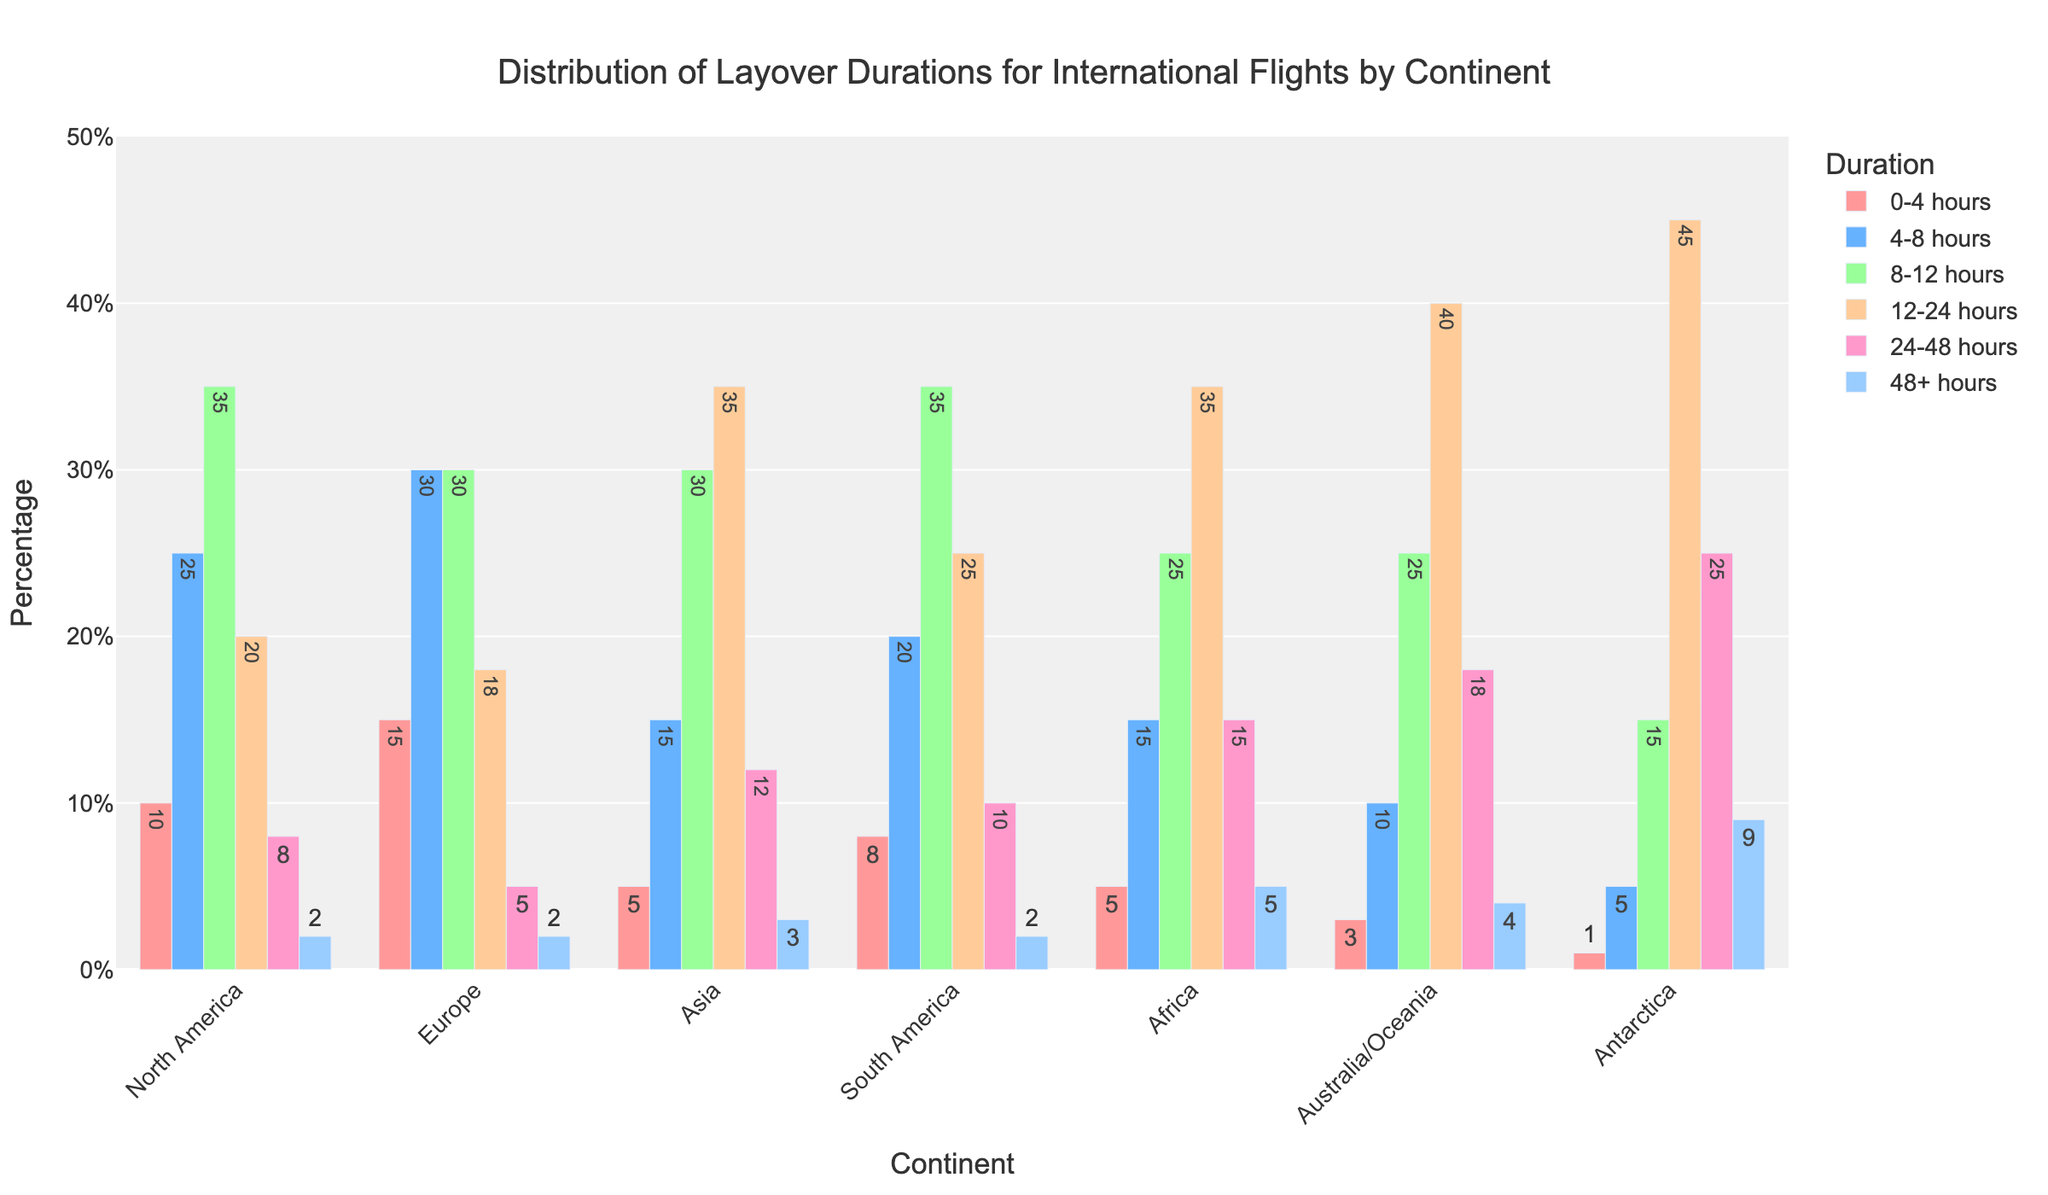Which continent has the highest percentage of layovers lasting 48+ hours? Antarctica has the highest percentage of layovers lasting 48+ hours, as its bar is the tallest among the 48+ hours category.
Answer: Antarctica Which two continents have the highest percentage of layovers in the 12-24 hours category? Antarctica and Australia/Oceania both have the highest percentage of layovers in the 12-24 hours category, as their bars are the tallest in this duration.
Answer: Antarctica, Australia/Oceania Is there any continent where the lowest percentage of layovers is in the 4-8 hours category? By looking at the bars, Antarctica has the lowest percentage in the 4-8 hours category compared to other durations.
Answer: Antarctica Compare the percentage of layovers of 8-12 hours between Asia and South America. Which continent has a higher percentage? Asia has 30% layovers in the 8-12 hours category, while South America also has 35%. Thus, South America has a higher percentage.
Answer: South America What's the total percentage of layovers between 24-48 hours and 48+ hours in Africa? Adding the percentages for Africa: 24-48 hours (15%) + 48+ hours (5%) = 20%.
Answer: 20% Which continent has the most balanced distribution across all layover durations? Europe has a relatively balanced distribution, as the bars for each duration are more evenly spread compared to other continents.
Answer: Europe Compare the visual heights of the bars for North America and Australia/Oceania in the 0-4 hours category. Which one is taller? North America’s bar in the 0-4 hours category is taller than Australia/Oceania's, indicating a higher percentage in that duration.
Answer: North America What is the difference in the percentage of layovers between the 0-4 hours and 4-8 hours categories in South America? South America has 8% in 0-4 hours and 20% in 4-8 hours. The difference is 20% - 8% = 12%.
Answer: 12% Which continent has the highest cumulative percentage of layovers in the 8-12, 12-24, and 24-48 hours categories combined? Adding the percentages for Antarctica: 8-12 hours (15%) + 12-24 hours (45%) + 24-48 hours (25%) = 85%, which is the highest compared to other continents.
Answer: Antarctica 